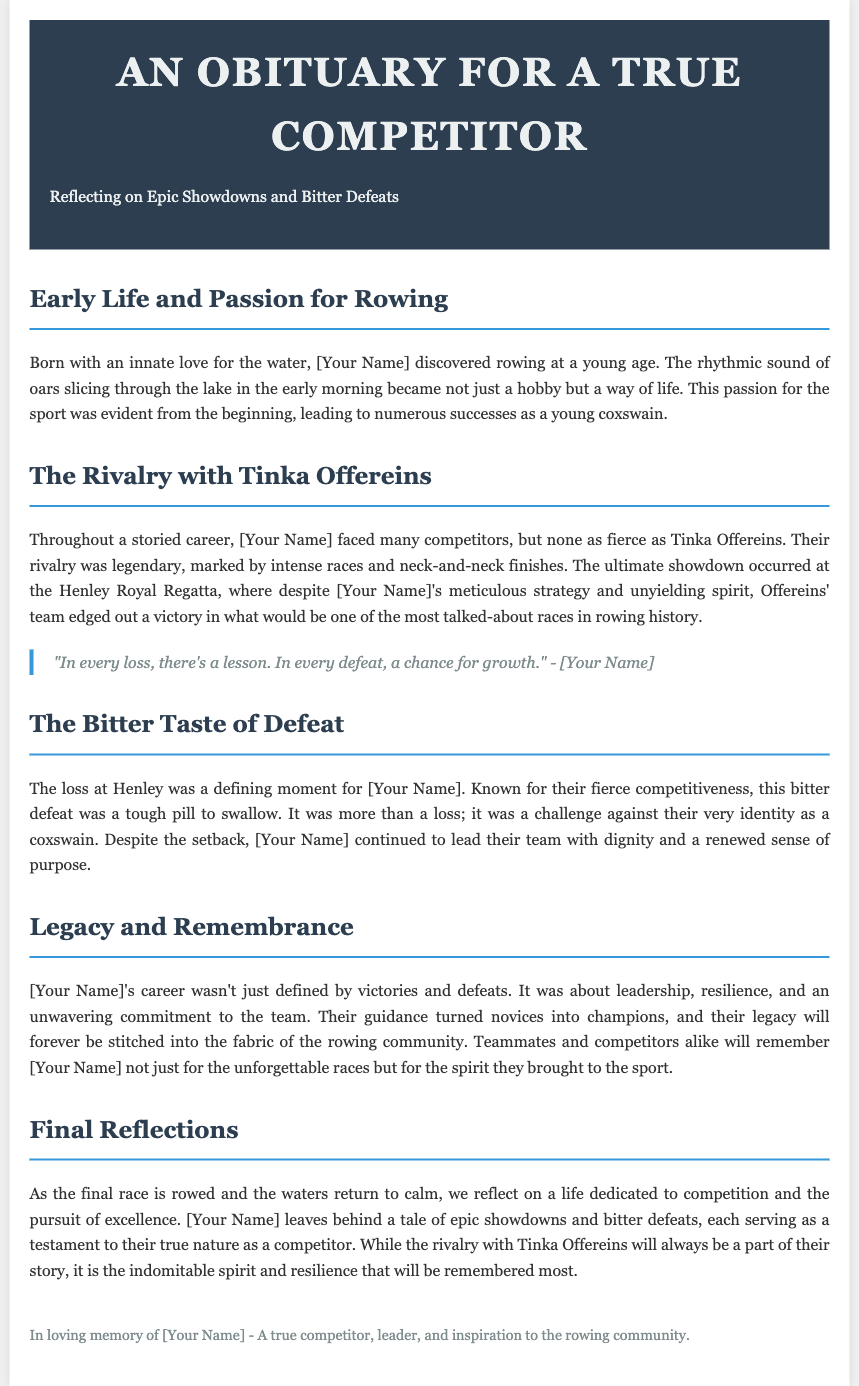What was the ultimate showdown for [Your Name]? The document mentions the Henley Royal Regatta as the ultimate showdown for [Your Name].
Answer: Henley Royal Regatta Who was [Your Name]'s fierce competitor? The obituary highlights Tinka Offereins as the most fierce competitor of [Your Name].
Answer: Tinka Offereins What is stated as a defining moment for [Your Name]? The loss at Henley is described as a defining moment for [Your Name].
Answer: The loss at Henley What did [Your Name] emphasize about losses? A quote from [Your Name] reflects on the lessons learned from losses.
Answer: A lesson What did [Your Name]'s guidance achieve in their team? The obituary states that [Your Name]'s guidance turned novices into champions.
Answer: Novices into champions How is [Your Name]’s legacy characterized in the document? The document states [Your Name]'s legacy is about leadership, resilience, and commitment to the team.
Answer: Leadership, resilience, commitment When did [Your Name] discover their love for rowing? The document implies [Your Name] discovered rowing at a young age, though no specific date is given.
Answer: At a young age What type of spirit will [Your Name] be remembered for? The obituary describes [Your Name] as having an indomitable spirit.
Answer: Indomitable spirit Which community will remember [Your Name]? The document specifies that the rowing community will remember [Your Name].
Answer: Rowing community 